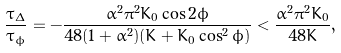<formula> <loc_0><loc_0><loc_500><loc_500>\frac { \tau _ { \Delta } } { \tau _ { \phi } } = - \frac { \alpha ^ { 2 } \pi ^ { 2 } K _ { 0 } \cos { 2 \phi } } { 4 8 ( 1 + \alpha ^ { 2 } ) ( K + K _ { 0 } \cos ^ { 2 } { \phi } ) } < \frac { \alpha ^ { 2 } \pi ^ { 2 } K _ { 0 } } { 4 8 K } ,</formula> 